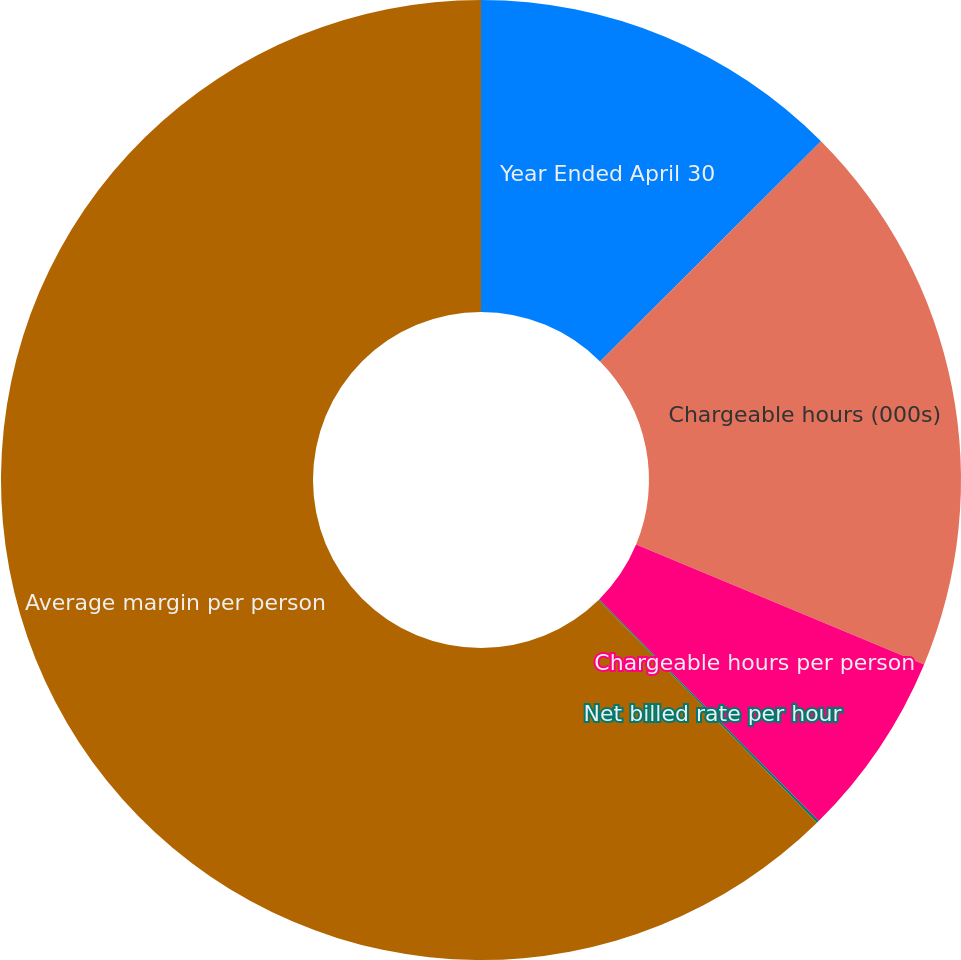Convert chart. <chart><loc_0><loc_0><loc_500><loc_500><pie_chart><fcel>Year Ended April 30<fcel>Chargeable hours (000s)<fcel>Chargeable hours per person<fcel>Net billed rate per hour<fcel>Average margin per person<nl><fcel>12.53%<fcel>18.75%<fcel>6.3%<fcel>0.08%<fcel>62.34%<nl></chart> 